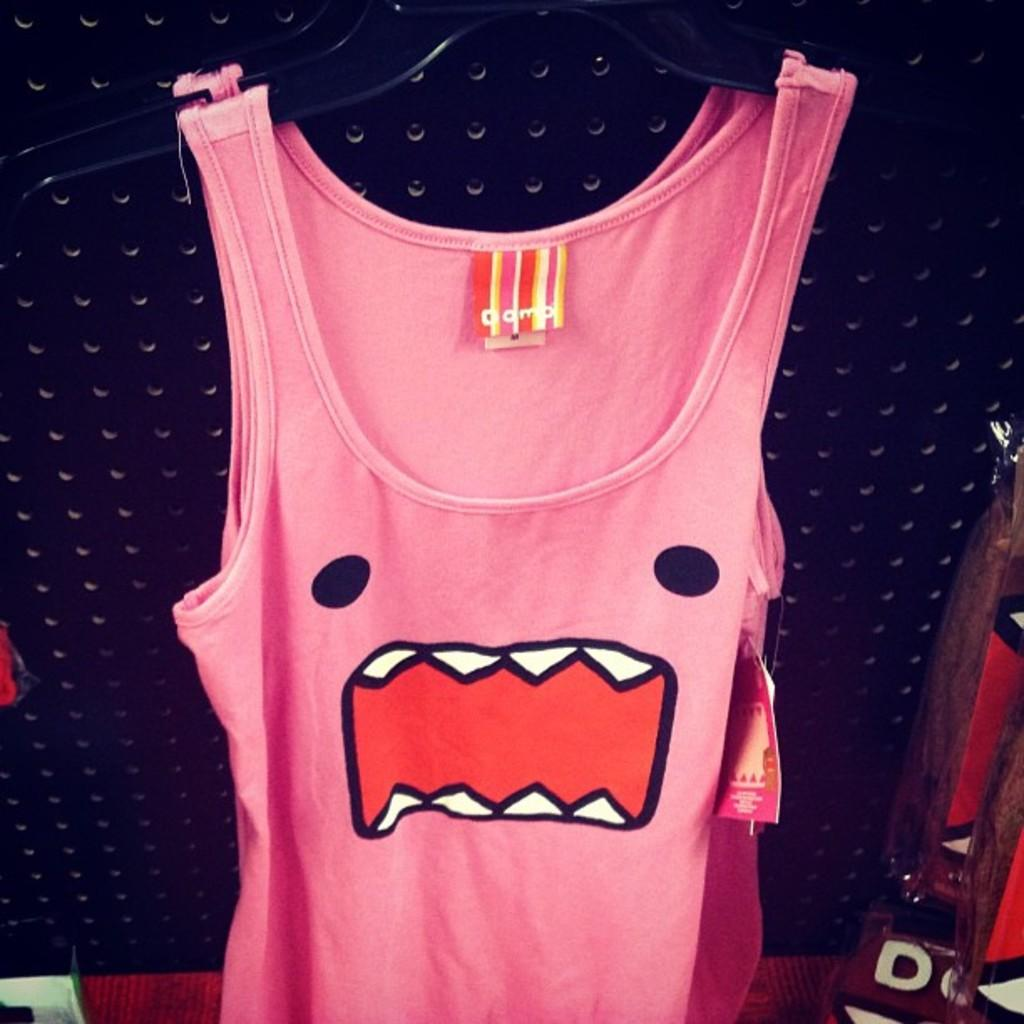What can be seen hanging on hangers in the image? There are clothes hanging on hangers in the image. What additional detail can be observed in the image? There is a tag in the image. What type of surface is present in the image? There is a board in the image. Can you describe any other objects in the image? There are other unspecified objects in the image. How many cars are parked near the mailbox in the image? There are no cars or mailbox present in the image. 